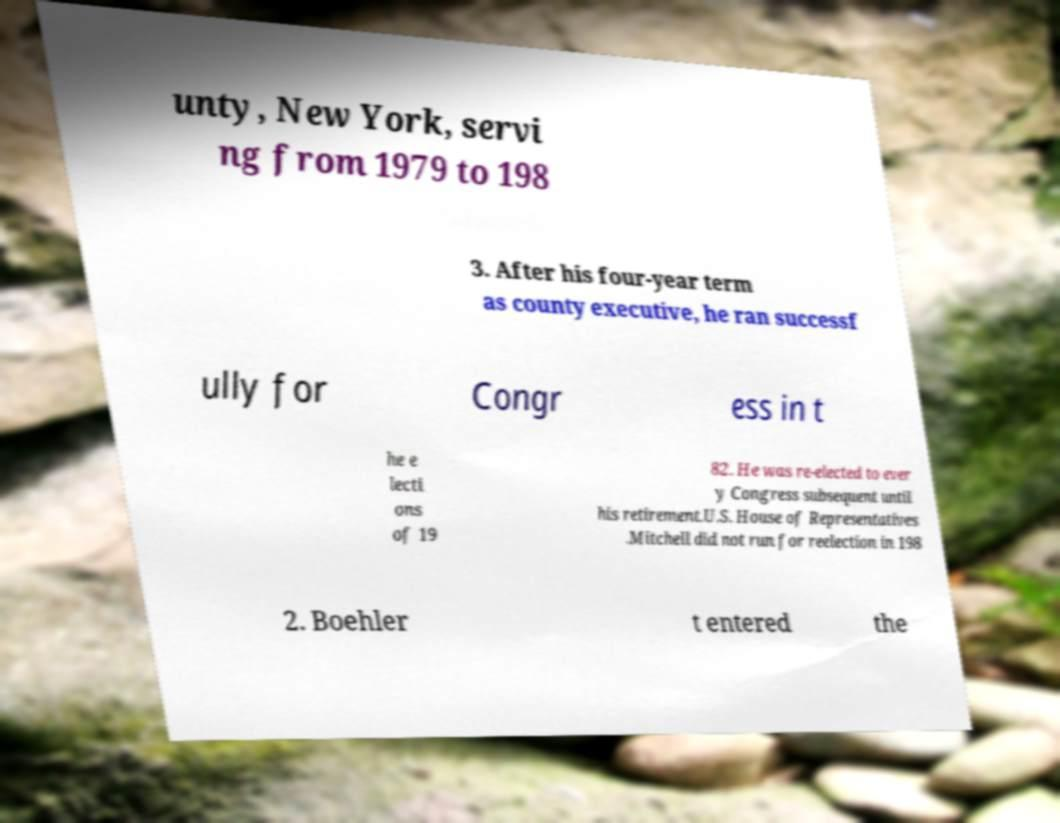Can you discuss the significance of reelections as mentioned in the image? Reelections, as noted in the text on the image, highlight a political figure's continued endorsement by the electorate, reflecting public trust and approval of their performance in office. The consecutive re-elections until retirement indicate a long period of political stability and the individual's significant impact on their community or constituency. 